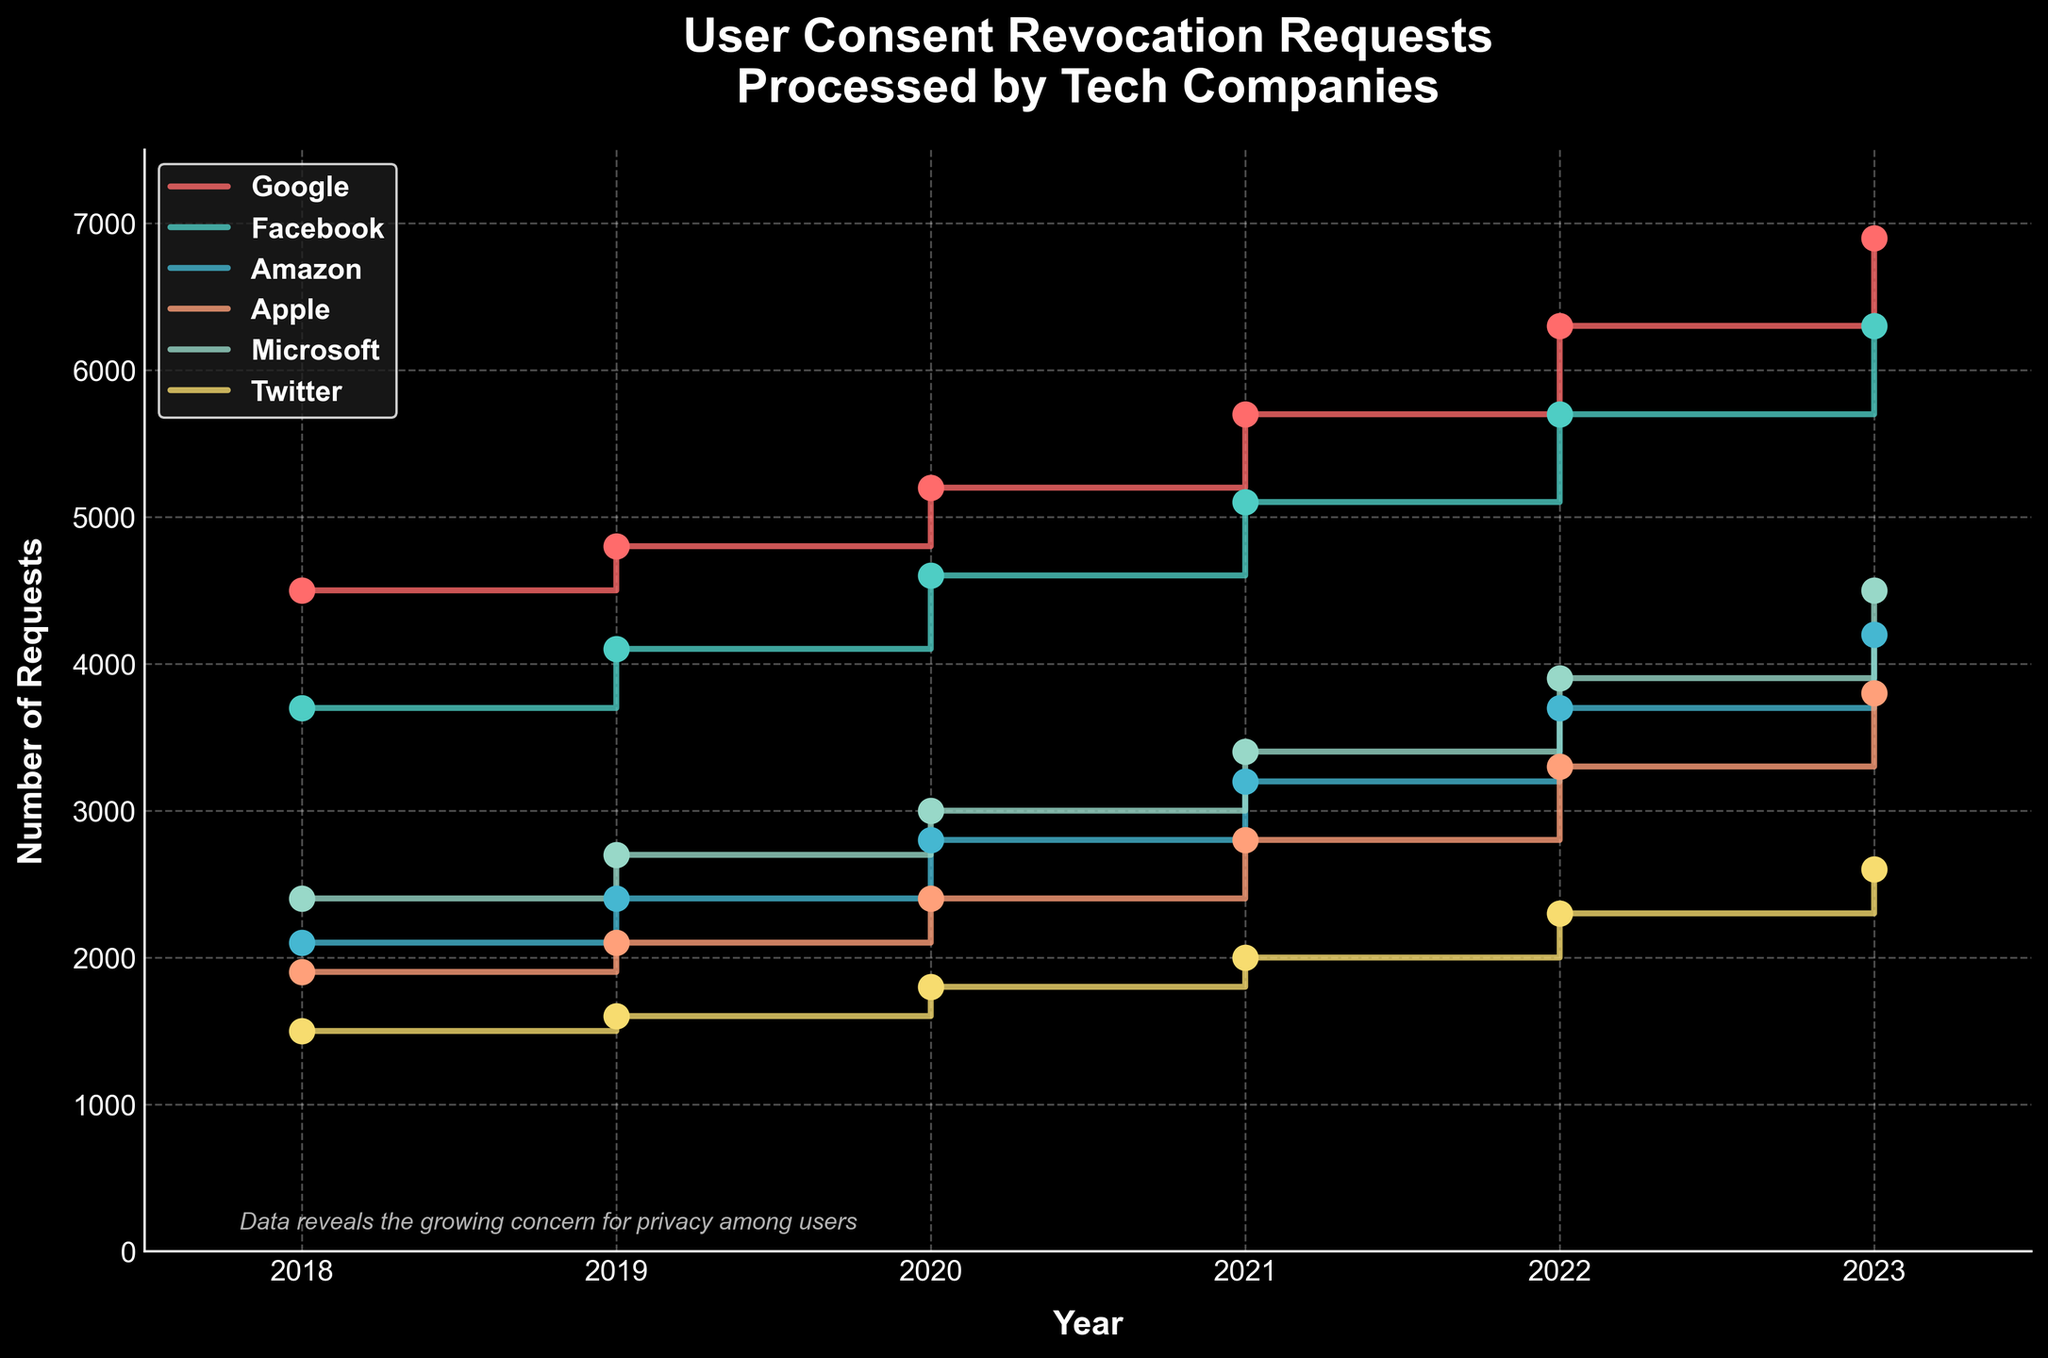How many total user consent revocation requests did Apple process in 2021? Locate the year 2021 on the x-axis and then find the corresponding point for Apple on the y-axis, which shows 2,800 requests
Answer: 2,800 Which company had the highest number of revocation requests in 2023? By examining the points and the step height at the year 2023, it is clear Google had the highest number of requests, with 6,900
Answer: Google What is the trend in user consent revocation requests processed by Amazon over the years? Observe the step heights along the curve for Amazon from 2018 to 2023; the plot shows an increasing trend year after year
Answer: Increasing Compare the total number of requests processed by Facebook and Twitter in 2020. Which one is higher? Locate both companies at the year 2020; Facebook processed 4,600 requests, while Twitter processed 1,800 requests. Facebook's number is higher than Twitter's
Answer: Facebook How many more revocation requests did Microsoft process in 2022 compared to 2018? Find Microsoft at both years: 3,900 in 2022 and 2,400 in 2018. The difference is 3,900 - 2,400 = 1,500
Answer: 1,500 What is the average number of requests processed by Facebook from 2018 to 2023? Find Facebook's values each year (3,700, 4,100, 4,600, 5,100, 5,700, 6,300), sum them up (29,500) and divide by the number of years (6): 29,500 / 6 ≈ 4,917
Answer: 4,917 Between which consecutive years did Apple see the largest increase in requests? Calculate the difference for each consecutive year and find the largest: 200 (2018-2019), 300 (2019-2020), 400 (2020-2021), 500 (2021-2022), 500 (2022-2023). The largest increase of 500 happened in 2021-2022 and 2022-2023
Answer: 2021-2022 and 2022-2023 Rank the companies from most to least in terms of the number of requests processed in 2023. For 2023, order the companies by their request numbers: Google (6,900), Facebook (6,300), Amazon (4,200), Apple (3,800), Microsoft (4,500), Twitter (2,600)
Answer: Google, Facebook, Microsoft, Amazon, Apple, Twitter Do any companies have a consistent increase every year from 2018 to 2023? Verify if each company’s requests increase every consecutive year. All companies (Google, Facebook, Amazon, Apple, Microsoft, Twitter) show a consistent increase each year on the stair plot
Answer: Yes What can you infer about overall user behavior towards privacy concerns based on the trends? The increasing number of requests across all companies indicates growing user concern for privacy over the years
Answer: Increasing concern 